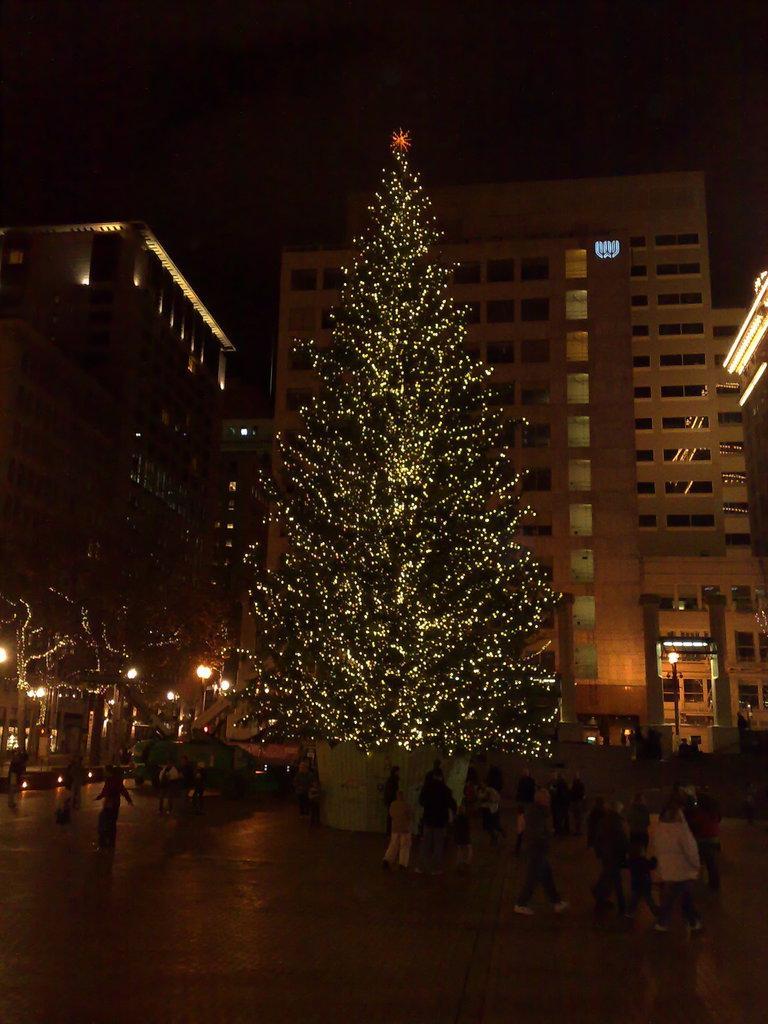Could you give a brief overview of what you see in this image? In this image we can see many buildings and trees. There are many people standing in the image. There is a vehicle in the image. 